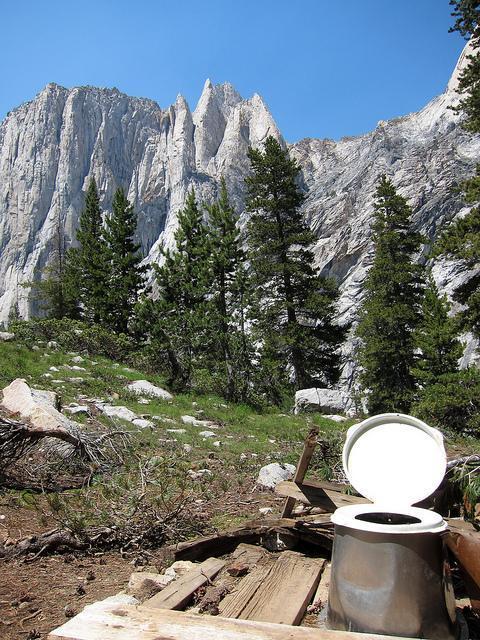How many people are in the photo?
Give a very brief answer. 0. 